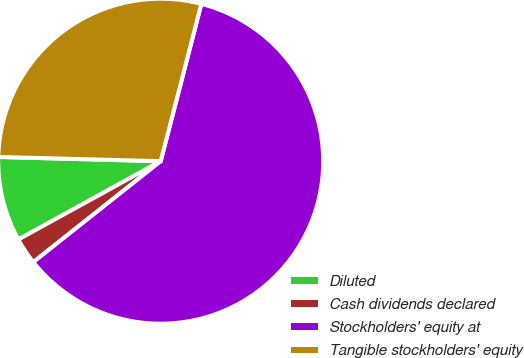<chart> <loc_0><loc_0><loc_500><loc_500><pie_chart><fcel>Diluted<fcel>Cash dividends declared<fcel>Stockholders' equity at<fcel>Tangible stockholders' equity<nl><fcel>8.42%<fcel>2.66%<fcel>60.31%<fcel>28.61%<nl></chart> 